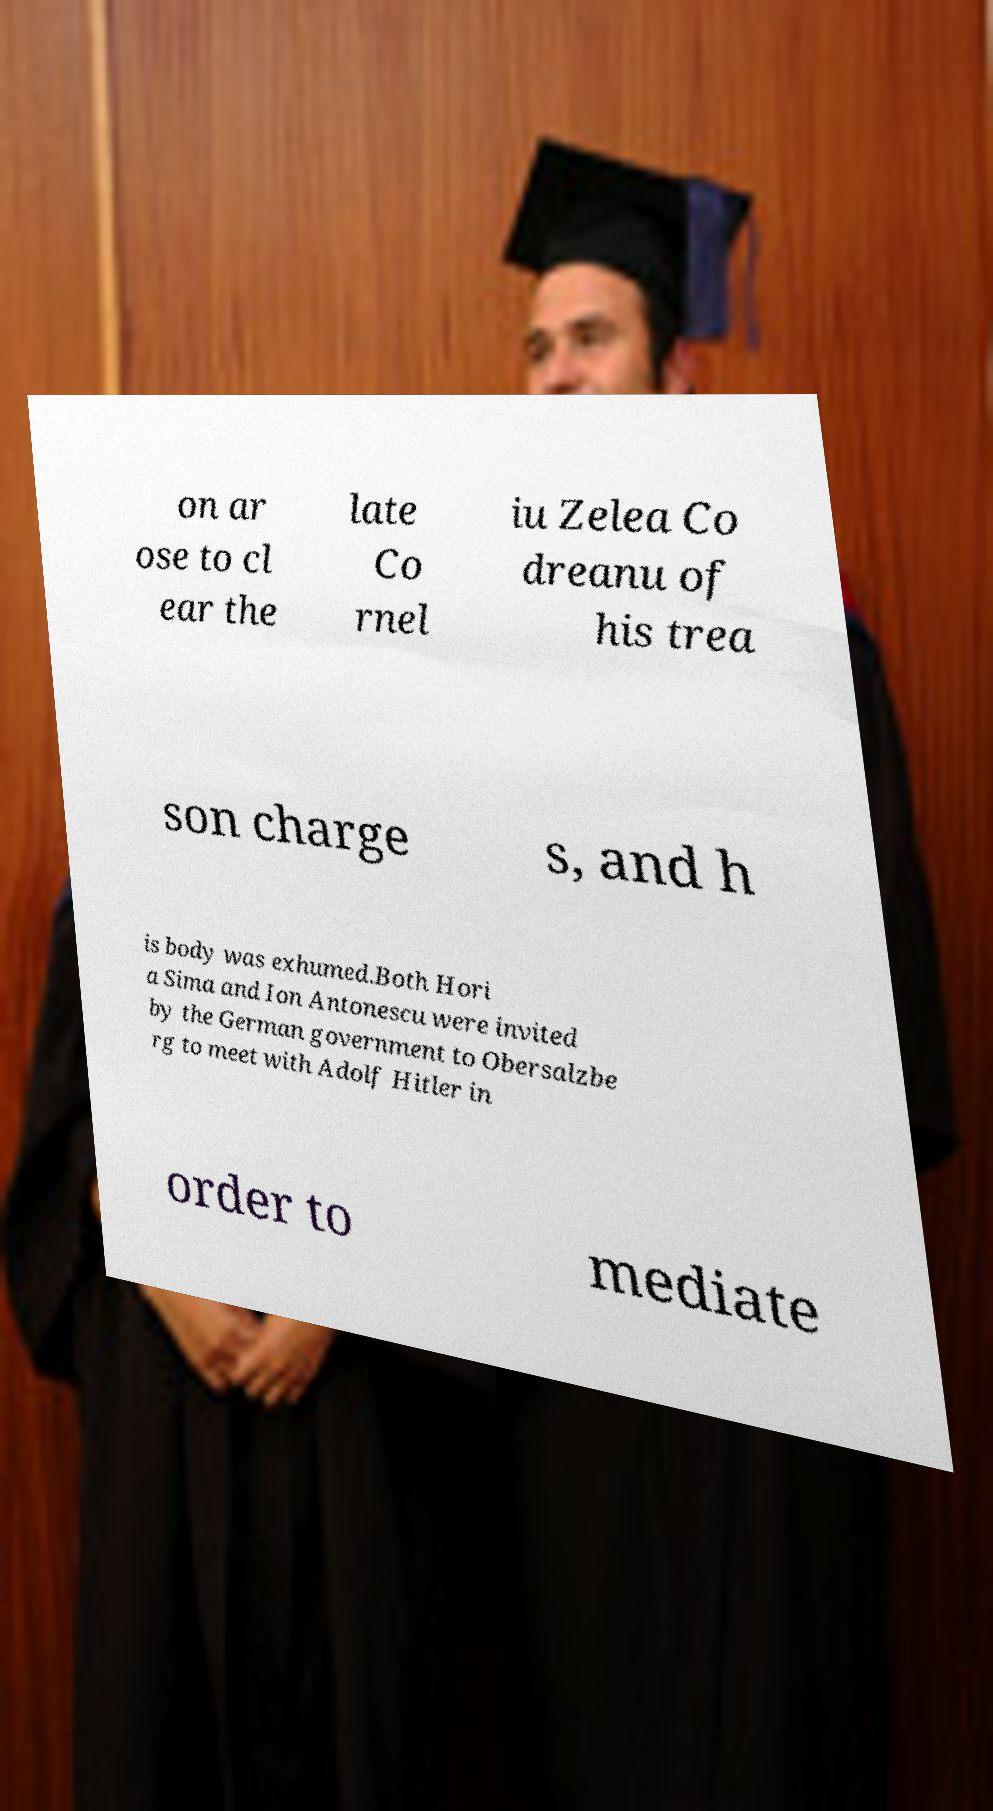Could you extract and type out the text from this image? on ar ose to cl ear the late Co rnel iu Zelea Co dreanu of his trea son charge s, and h is body was exhumed.Both Hori a Sima and Ion Antonescu were invited by the German government to Obersalzbe rg to meet with Adolf Hitler in order to mediate 